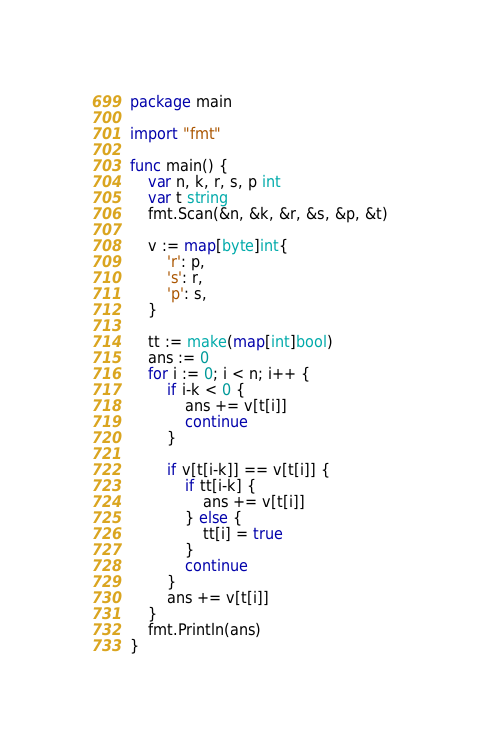Convert code to text. <code><loc_0><loc_0><loc_500><loc_500><_Go_>package main

import "fmt"

func main() {
	var n, k, r, s, p int
	var t string
	fmt.Scan(&n, &k, &r, &s, &p, &t)

	v := map[byte]int{
		'r': p,
		's': r,
		'p': s,
	}

	tt := make(map[int]bool)
	ans := 0
	for i := 0; i < n; i++ {
		if i-k < 0 {
			ans += v[t[i]]
			continue
		}

		if v[t[i-k]] == v[t[i]] {
			if tt[i-k] {
				ans += v[t[i]]
			} else {
				tt[i] = true
			}
			continue
		}
		ans += v[t[i]]
	}
	fmt.Println(ans)
}
</code> 